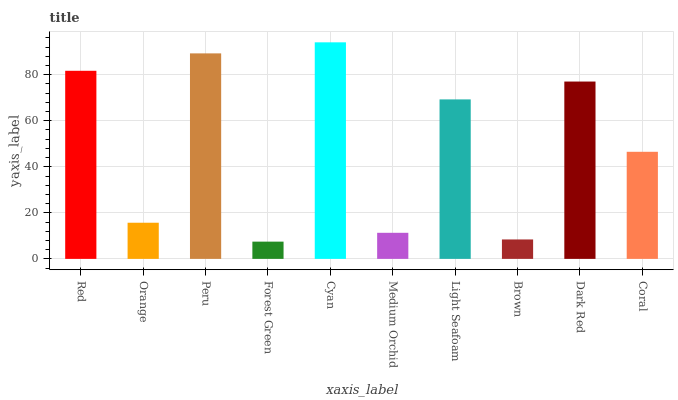Is Forest Green the minimum?
Answer yes or no. Yes. Is Cyan the maximum?
Answer yes or no. Yes. Is Orange the minimum?
Answer yes or no. No. Is Orange the maximum?
Answer yes or no. No. Is Red greater than Orange?
Answer yes or no. Yes. Is Orange less than Red?
Answer yes or no. Yes. Is Orange greater than Red?
Answer yes or no. No. Is Red less than Orange?
Answer yes or no. No. Is Light Seafoam the high median?
Answer yes or no. Yes. Is Coral the low median?
Answer yes or no. Yes. Is Dark Red the high median?
Answer yes or no. No. Is Brown the low median?
Answer yes or no. No. 